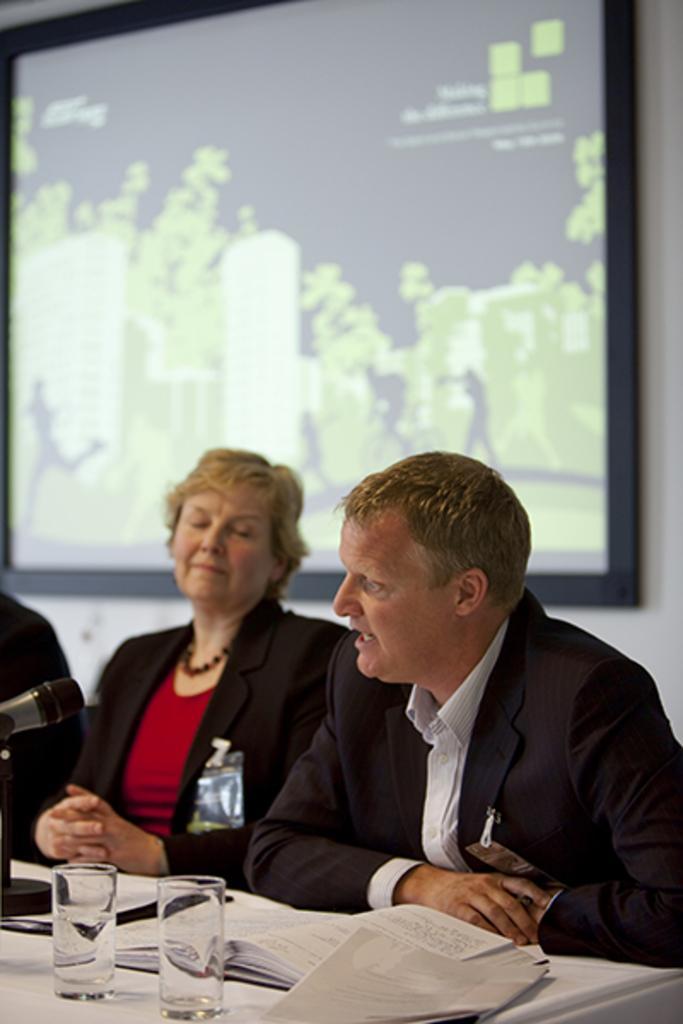Can you describe this image briefly? In the background we can see a screen on the wall. In this picture we can see a woman and a man. On a table we can see book, water glasses, microphone and an object. 